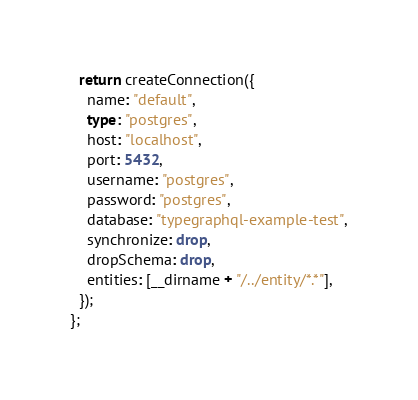<code> <loc_0><loc_0><loc_500><loc_500><_TypeScript_>  return createConnection({
    name: "default",
    type: "postgres",
    host: "localhost",
    port: 5432,
    username: "postgres",
    password: "postgres",
    database: "typegraphql-example-test",
    synchronize: drop,
    dropSchema: drop,
    entities: [__dirname + "/../entity/*.*"],
  });
};
</code> 